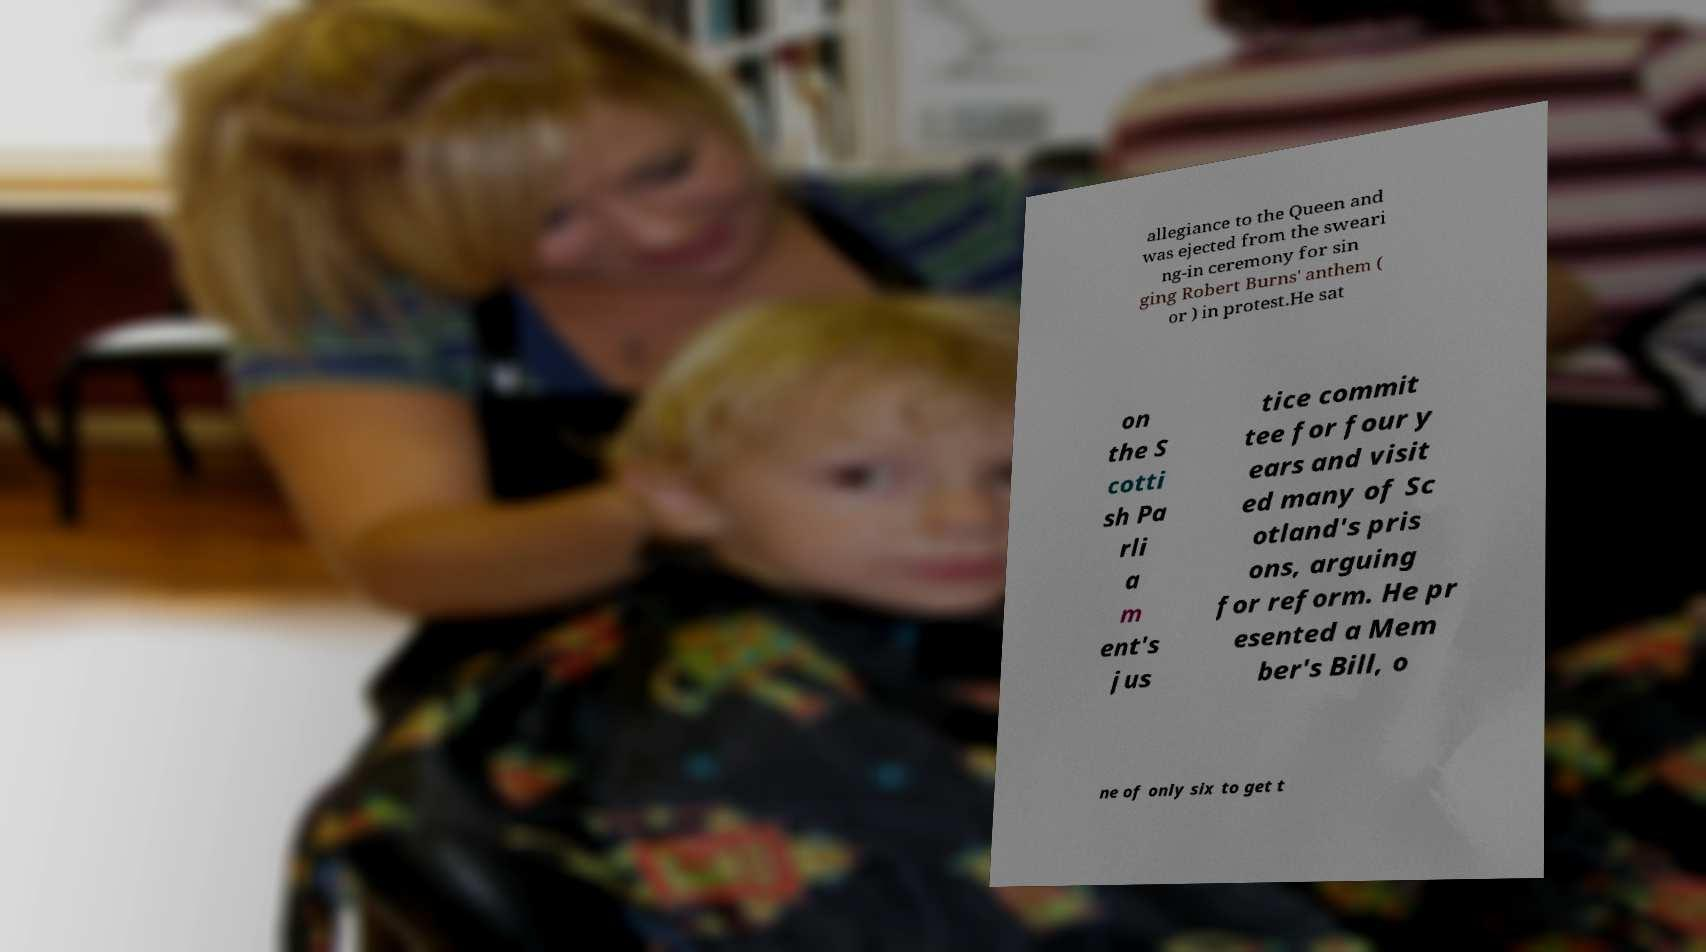Could you assist in decoding the text presented in this image and type it out clearly? allegiance to the Queen and was ejected from the sweari ng-in ceremony for sin ging Robert Burns' anthem ( or ) in protest.He sat on the S cotti sh Pa rli a m ent's jus tice commit tee for four y ears and visit ed many of Sc otland's pris ons, arguing for reform. He pr esented a Mem ber's Bill, o ne of only six to get t 